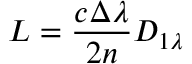<formula> <loc_0><loc_0><loc_500><loc_500>L = \frac { c \Delta \lambda } { 2 n } D _ { 1 \lambda }</formula> 